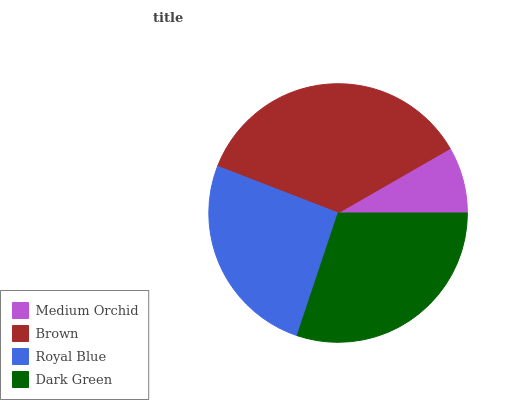Is Medium Orchid the minimum?
Answer yes or no. Yes. Is Brown the maximum?
Answer yes or no. Yes. Is Royal Blue the minimum?
Answer yes or no. No. Is Royal Blue the maximum?
Answer yes or no. No. Is Brown greater than Royal Blue?
Answer yes or no. Yes. Is Royal Blue less than Brown?
Answer yes or no. Yes. Is Royal Blue greater than Brown?
Answer yes or no. No. Is Brown less than Royal Blue?
Answer yes or no. No. Is Dark Green the high median?
Answer yes or no. Yes. Is Royal Blue the low median?
Answer yes or no. Yes. Is Medium Orchid the high median?
Answer yes or no. No. Is Dark Green the low median?
Answer yes or no. No. 